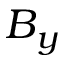Convert formula to latex. <formula><loc_0><loc_0><loc_500><loc_500>B _ { y }</formula> 